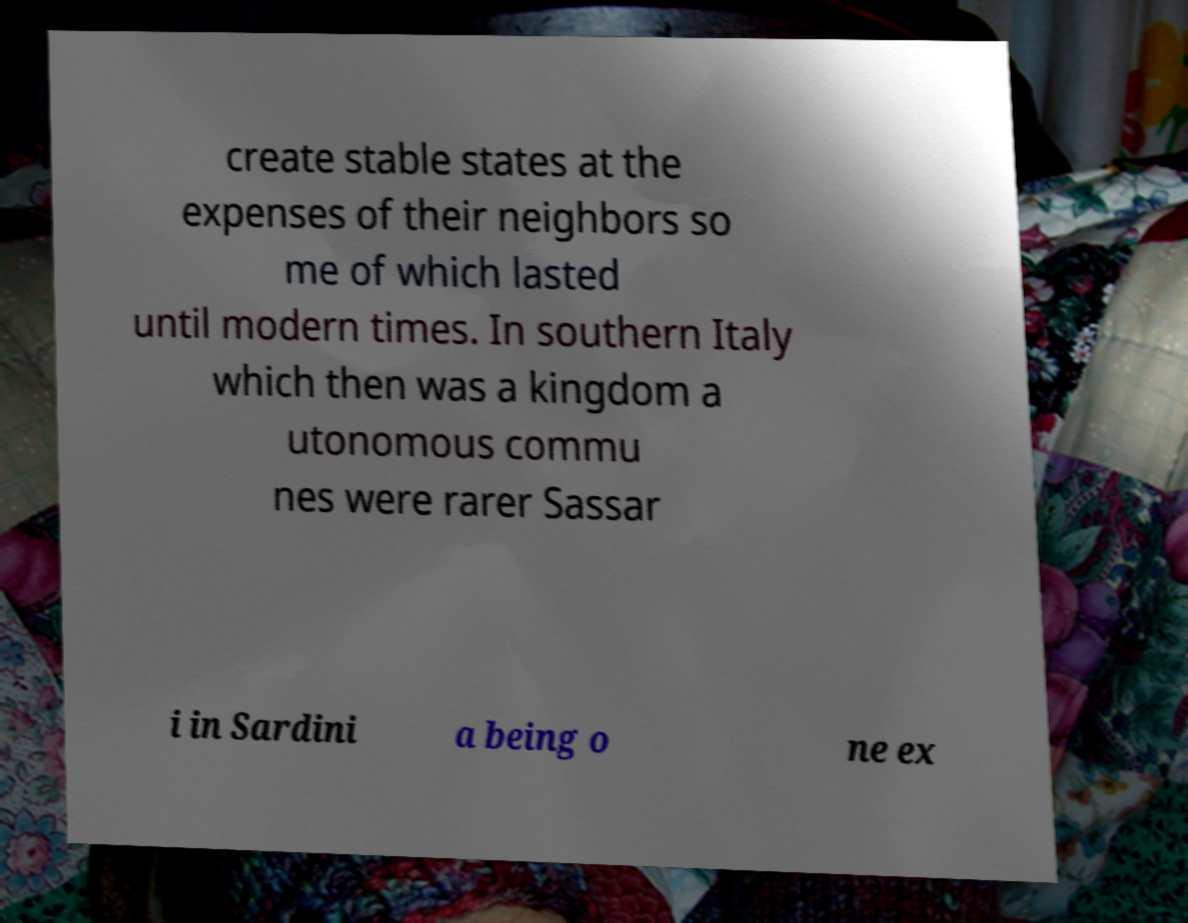Please read and relay the text visible in this image. What does it say? create stable states at the expenses of their neighbors so me of which lasted until modern times. In southern Italy which then was a kingdom a utonomous commu nes were rarer Sassar i in Sardini a being o ne ex 